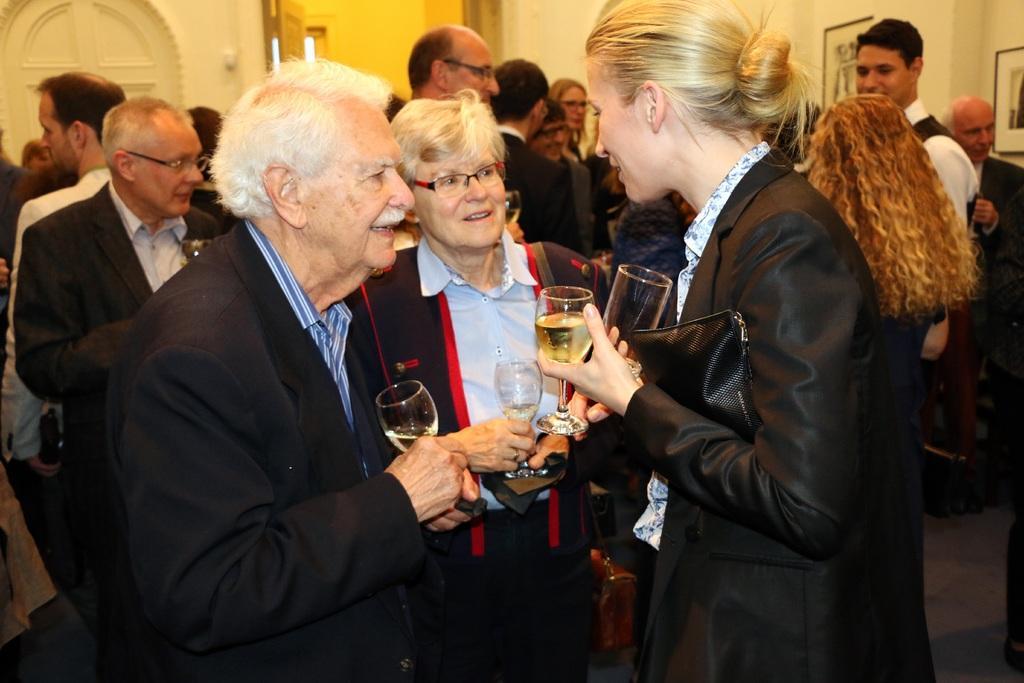Could you give a brief overview of what you see in this image? In this image, we can see persons wearing clothes. There are some persons holding glasses with their hands. There are photo frames in the top right of the image. 